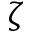Convert formula to latex. <formula><loc_0><loc_0><loc_500><loc_500>\zeta</formula> 